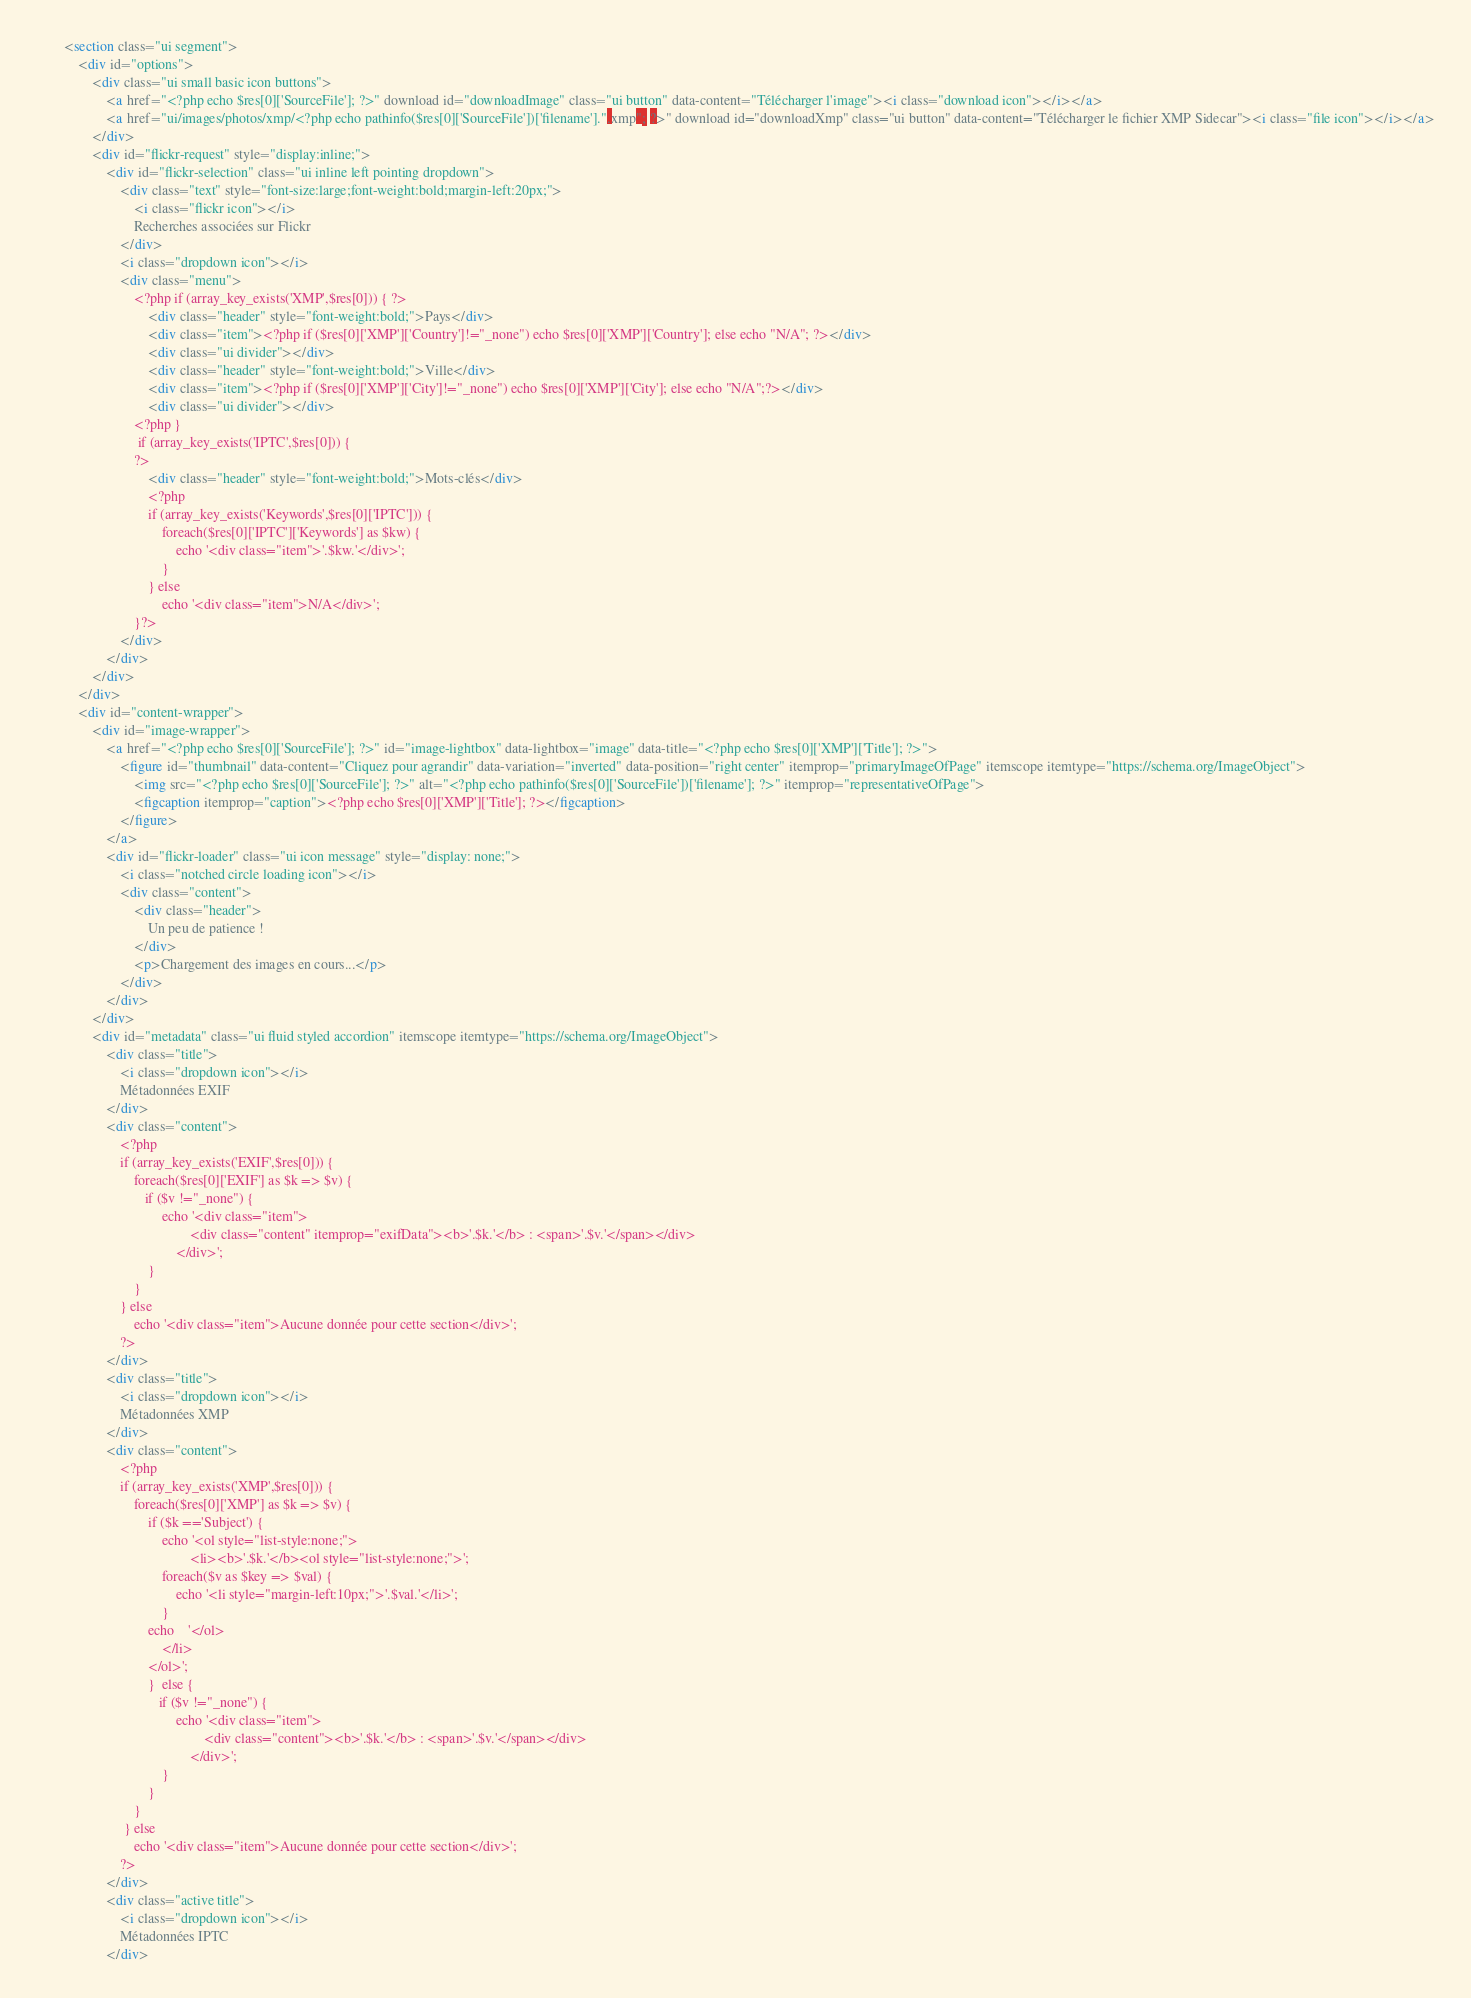Convert code to text. <code><loc_0><loc_0><loc_500><loc_500><_HTML_>        <section class="ui segment">
            <div id="options">
                <div class="ui small basic icon buttons">
                    <a href="<?php echo $res[0]['SourceFile']; ?>" download id="downloadImage" class="ui button" data-content="Télécharger l'image"><i class="download icon"></i></a>
                    <a href="ui/images/photos/xmp/<?php echo pathinfo($res[0]['SourceFile'])['filename'].".xmp"; ?>" download id="downloadXmp" class="ui button" data-content="Télécharger le fichier XMP Sidecar"><i class="file icon"></i></a>
                </div>
                <div id="flickr-request" style="display:inline;">
                    <div id="flickr-selection" class="ui inline left pointing dropdown">
                        <div class="text" style="font-size:large;font-weight:bold;margin-left:20px;">
                            <i class="flickr icon"></i>
                            Recherches associées sur Flickr
                        </div>
                        <i class="dropdown icon"></i>
                        <div class="menu">
                            <?php if (array_key_exists('XMP',$res[0])) { ?>
                                <div class="header" style="font-weight:bold;">Pays</div>
                                <div class="item"><?php if ($res[0]['XMP']['Country']!="_none") echo $res[0]['XMP']['Country']; else echo "N/A"; ?></div>
                                <div class="ui divider"></div>
                                <div class="header" style="font-weight:bold;">Ville</div>
                                <div class="item"><?php if ($res[0]['XMP']['City']!="_none") echo $res[0]['XMP']['City']; else echo "N/A";?></div>
                                <div class="ui divider"></div>
                            <?php }
                             if (array_key_exists('IPTC',$res[0])) {
                            ?>
                                <div class="header" style="font-weight:bold;">Mots-clés</div>
                                <?php
                                if (array_key_exists('Keywords',$res[0]['IPTC'])) {
                                    foreach($res[0]['IPTC']['Keywords'] as $kw) {
                                        echo '<div class="item">'.$kw.'</div>';
                                    }
                                } else
                                    echo '<div class="item">N/A</div>';
                            }?>
                        </div>
                    </div>
                </div>
            </div>
            <div id="content-wrapper">
                <div id="image-wrapper">
                    <a href="<?php echo $res[0]['SourceFile']; ?>" id="image-lightbox" data-lightbox="image" data-title="<?php echo $res[0]['XMP']['Title']; ?>">
                        <figure id="thumbnail" data-content="Cliquez pour agrandir" data-variation="inverted" data-position="right center" itemprop="primaryImageOfPage" itemscope itemtype="https://schema.org/ImageObject">
                            <img src="<?php echo $res[0]['SourceFile']; ?>" alt="<?php echo pathinfo($res[0]['SourceFile'])['filename']; ?>" itemprop="representativeOfPage">
                            <figcaption itemprop="caption"><?php echo $res[0]['XMP']['Title']; ?></figcaption>
                        </figure>
                    </a>
                    <div id="flickr-loader" class="ui icon message" style="display: none;">
                        <i class="notched circle loading icon"></i>
                        <div class="content">
                            <div class="header">
                                Un peu de patience !
                            </div>
                            <p>Chargement des images en cours...</p>
                        </div>
                    </div>
                </div>
                <div id="metadata" class="ui fluid styled accordion" itemscope itemtype="https://schema.org/ImageObject">
                    <div class="title">
                        <i class="dropdown icon"></i>
                        Métadonnées EXIF
                    </div>
                    <div class="content">
                        <?php
                        if (array_key_exists('EXIF',$res[0])) {
                            foreach($res[0]['EXIF'] as $k => $v) {
                               if ($v !="_none") {
                                    echo '<div class="item">
                                            <div class="content" itemprop="exifData"><b>'.$k.'</b> : <span>'.$v.'</span></div>
                                        </div>';
                                }
                            }
                        } else
                            echo '<div class="item">Aucune donnée pour cette section</div>';
                        ?>
                    </div>
                    <div class="title">
                        <i class="dropdown icon"></i>
                        Métadonnées XMP
                    </div>
                    <div class="content">
                        <?php
                        if (array_key_exists('XMP',$res[0])) {
                            foreach($res[0]['XMP'] as $k => $v) {
                                if ($k =='Subject') {
                                    echo '<ol style="list-style:none;">
                                            <li><b>'.$k.'</b><ol style="list-style:none;">';
                                    foreach($v as $key => $val) {
                                        echo '<li style="margin-left:10px;">'.$val.'</li>';
                                    }
                                echo    '</ol>
                                    </li>
                                </ol>';
                                }  else {
                                   if ($v !="_none") {
                                        echo '<div class="item">
                                                <div class="content"><b>'.$k.'</b> : <span>'.$v.'</span></div>
                                            </div>';
                                    }
                                }
                            }
                         } else
                            echo '<div class="item">Aucune donnée pour cette section</div>';
                        ?>
                    </div>
                    <div class="active title">
                        <i class="dropdown icon"></i>
                        Métadonnées IPTC
                    </div></code> 